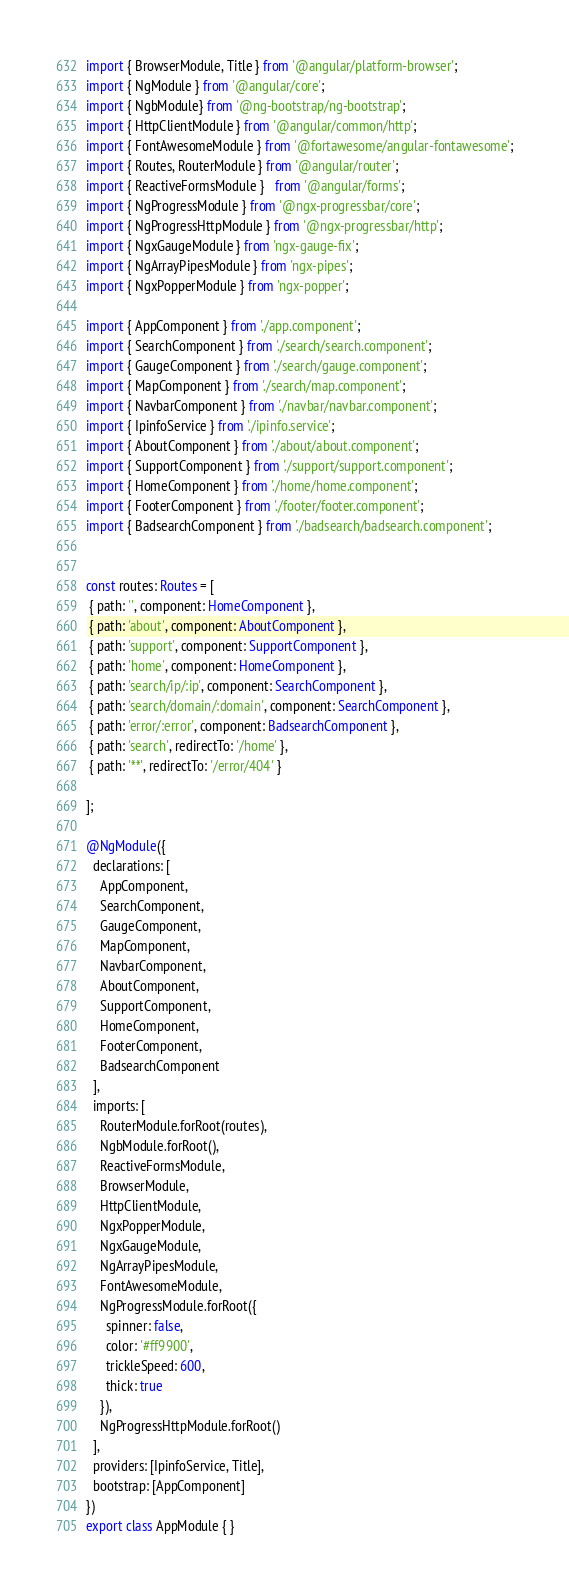Convert code to text. <code><loc_0><loc_0><loc_500><loc_500><_TypeScript_>import { BrowserModule, Title } from '@angular/platform-browser';
import { NgModule } from '@angular/core';
import { NgbModule} from '@ng-bootstrap/ng-bootstrap';
import { HttpClientModule } from '@angular/common/http';
import { FontAwesomeModule } from '@fortawesome/angular-fontawesome';
import { Routes, RouterModule } from '@angular/router';
import { ReactiveFormsModule }   from '@angular/forms';
import { NgProgressModule } from '@ngx-progressbar/core';
import { NgProgressHttpModule } from '@ngx-progressbar/http';
import { NgxGaugeModule } from 'ngx-gauge-fix';
import { NgArrayPipesModule } from 'ngx-pipes';
import { NgxPopperModule } from 'ngx-popper';

import { AppComponent } from './app.component';
import { SearchComponent } from './search/search.component';
import { GaugeComponent } from './search/gauge.component';
import { MapComponent } from './search/map.component';
import { NavbarComponent } from './navbar/navbar.component';
import { IpinfoService } from './ipinfo.service';
import { AboutComponent } from './about/about.component';
import { SupportComponent } from './support/support.component';
import { HomeComponent } from './home/home.component';
import { FooterComponent } from './footer/footer.component';
import { BadsearchComponent } from './badsearch/badsearch.component';


const routes: Routes = [
 { path: '', component: HomeComponent },
 { path: 'about', component: AboutComponent },
 { path: 'support', component: SupportComponent },
 { path: 'home', component: HomeComponent },
 { path: 'search/ip/:ip', component: SearchComponent },
 { path: 'search/domain/:domain', component: SearchComponent },
 { path: 'error/:error', component: BadsearchComponent },
 { path: 'search', redirectTo: '/home' },
 { path: '**', redirectTo: '/error/404' }

];

@NgModule({
  declarations: [
    AppComponent,
    SearchComponent,
    GaugeComponent,
    MapComponent,
    NavbarComponent,
    AboutComponent,
    SupportComponent,
    HomeComponent,
    FooterComponent,
    BadsearchComponent
  ],
  imports: [
    RouterModule.forRoot(routes),
    NgbModule.forRoot(),
    ReactiveFormsModule,
    BrowserModule,
    HttpClientModule,
    NgxPopperModule,
    NgxGaugeModule,
    NgArrayPipesModule,
    FontAwesomeModule,
    NgProgressModule.forRoot({
      spinner: false,
      color: '#ff9900',
      trickleSpeed: 600,
      thick: true
    }),
    NgProgressHttpModule.forRoot()
  ],
  providers: [IpinfoService, Title],
  bootstrap: [AppComponent]
})
export class AppModule { }
</code> 